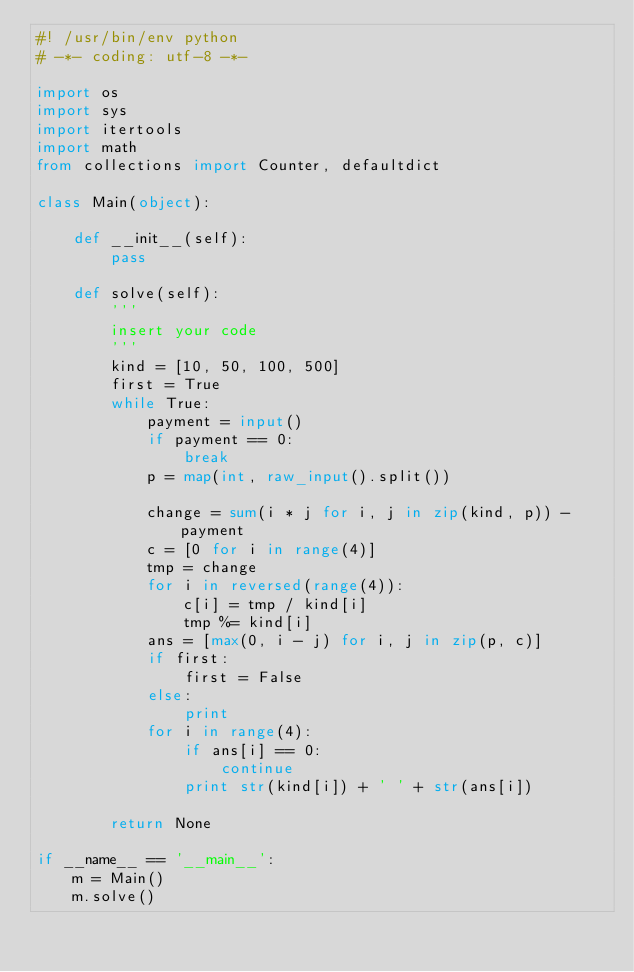<code> <loc_0><loc_0><loc_500><loc_500><_Python_>#! /usr/bin/env python
# -*- coding: utf-8 -*-

import os
import sys
import itertools
import math
from collections import Counter, defaultdict

class Main(object):
    
    def __init__(self):
        pass

    def solve(self):
        '''
        insert your code
        '''
        kind = [10, 50, 100, 500]
        first = True
        while True:            
            payment = input()
            if payment == 0:
                break
            p = map(int, raw_input().split())

            change = sum(i * j for i, j in zip(kind, p)) - payment
            c = [0 for i in range(4)]
            tmp = change
            for i in reversed(range(4)):
                c[i] = tmp / kind[i]
                tmp %= kind[i]
            ans = [max(0, i - j) for i, j in zip(p, c)]
            if first:
                first = False
            else:
                print
            for i in range(4):
                if ans[i] == 0:
                    continue
                print str(kind[i]) + ' ' + str(ans[i])
        
        return None

if __name__ == '__main__':
    m = Main()
    m.solve()</code> 